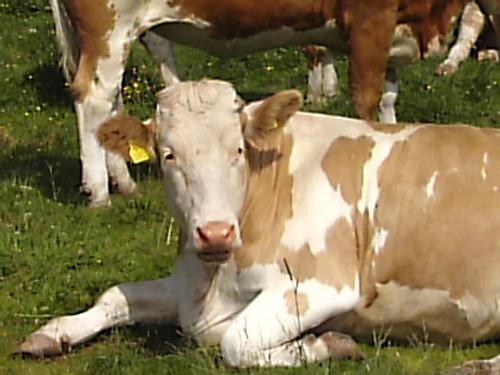Is there a tag in the cow's ear?
Write a very short answer. Yes. Which direction is the cow looking?
Write a very short answer. At camera. Is this bull?
Quick response, please. No. What color is the cow?
Keep it brief. Brown and white. 